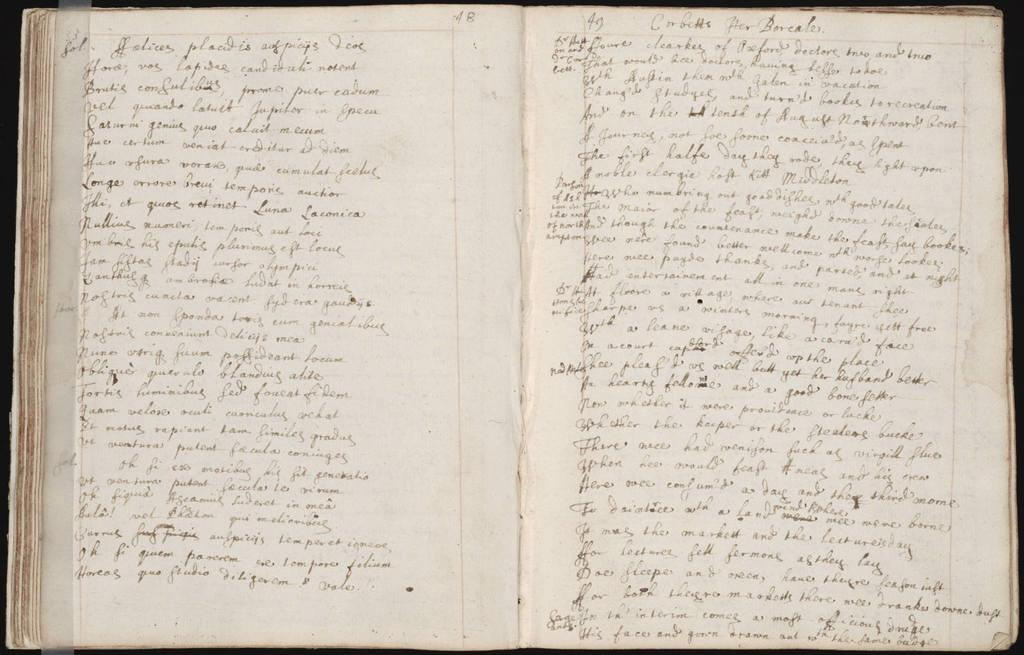What is the main object in the image? There is an open book in the image. What can be seen on the open book? Something is written on the open book. What type of coat is the person wearing while learning from the open book in the image? There is no person or coat present in the image; it only features an open book with something written on it. 